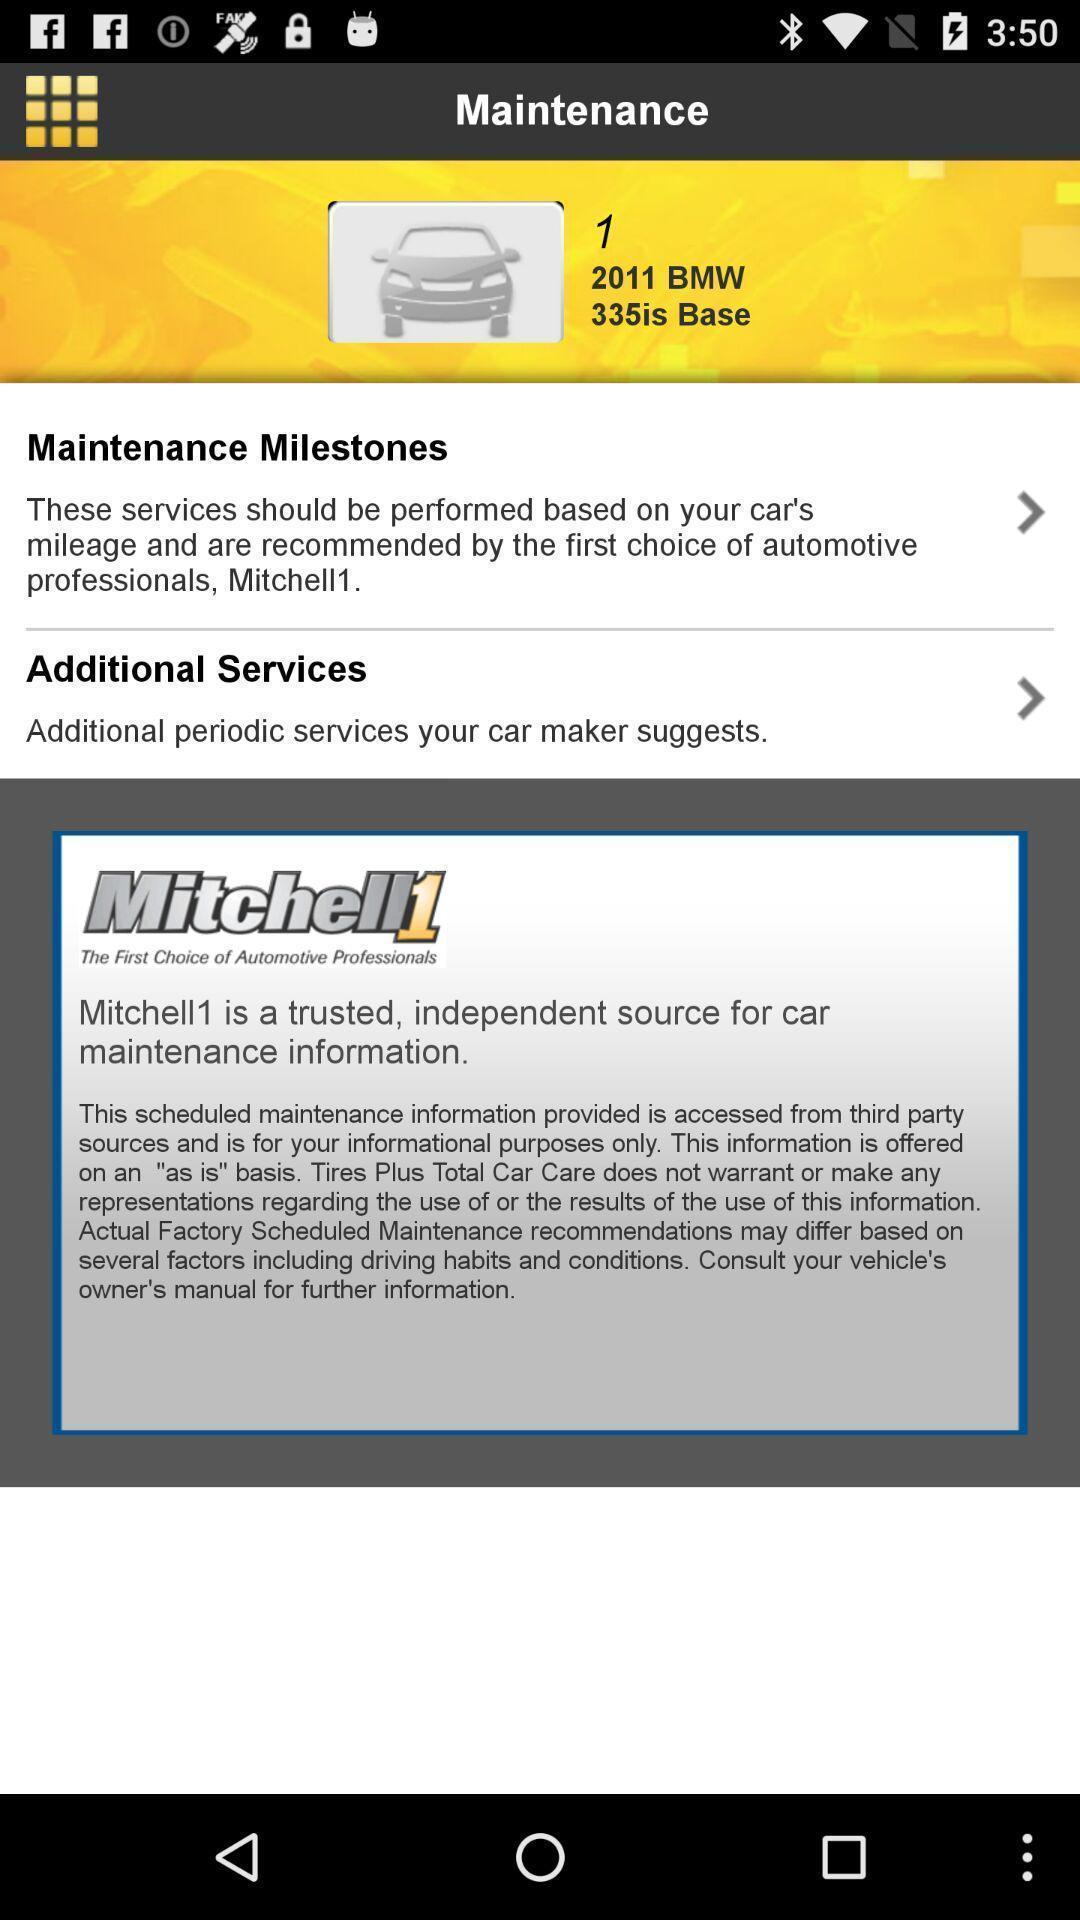Give me a summary of this screen capture. Screen displaying about maintenance app. 